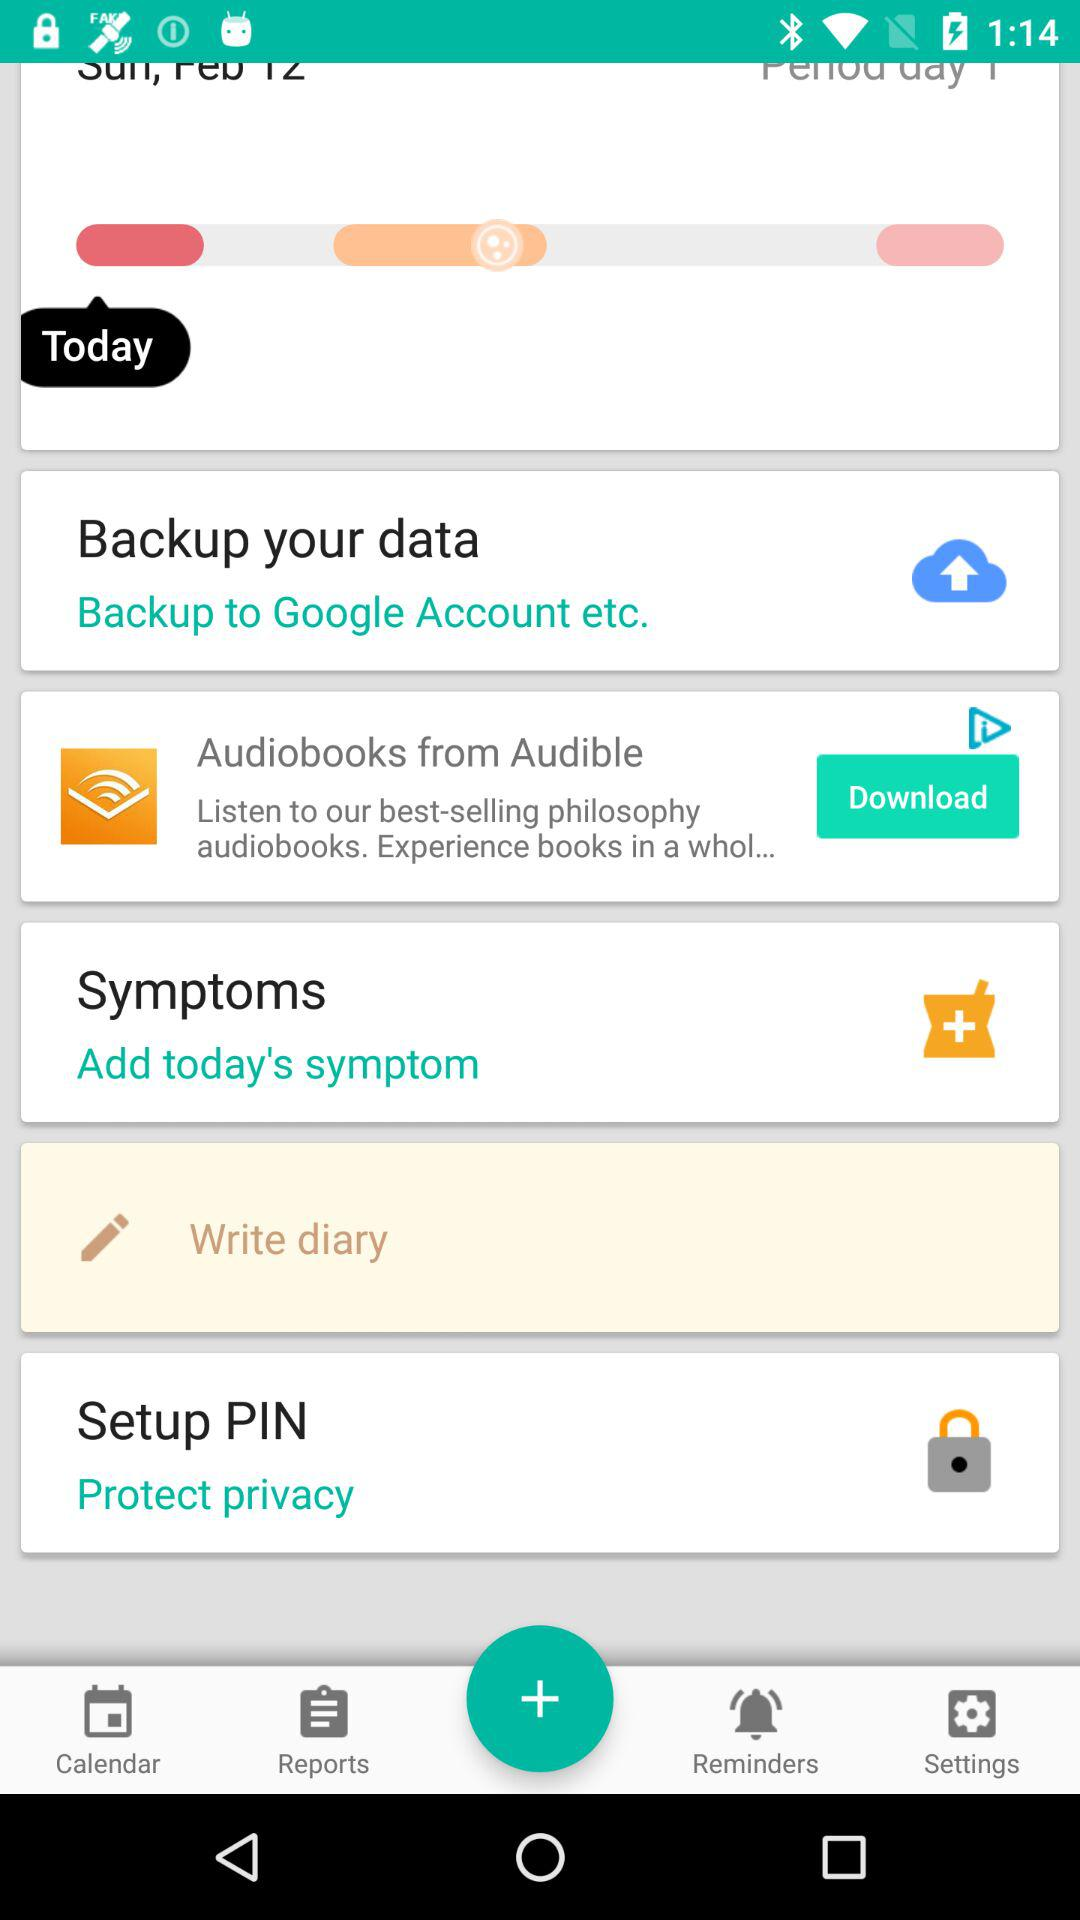What is the date?
When the provided information is insufficient, respond with <no answer>. <no answer> 